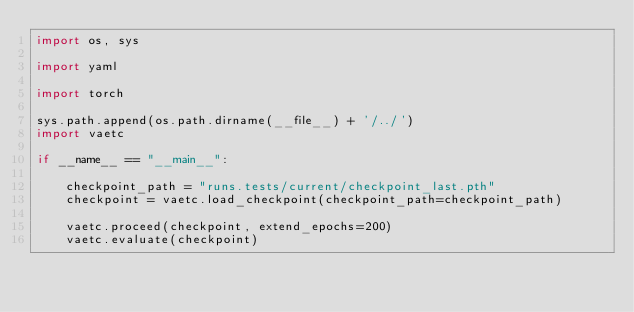Convert code to text. <code><loc_0><loc_0><loc_500><loc_500><_Python_>import os, sys

import yaml

import torch

sys.path.append(os.path.dirname(__file__) + '/../')
import vaetc

if __name__ == "__main__":

    checkpoint_path = "runs.tests/current/checkpoint_last.pth"
    checkpoint = vaetc.load_checkpoint(checkpoint_path=checkpoint_path)

    vaetc.proceed(checkpoint, extend_epochs=200)
    vaetc.evaluate(checkpoint)</code> 